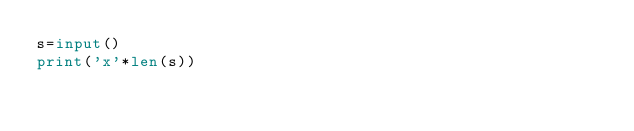<code> <loc_0><loc_0><loc_500><loc_500><_Python_>s=input()
print('x'*len(s))
</code> 